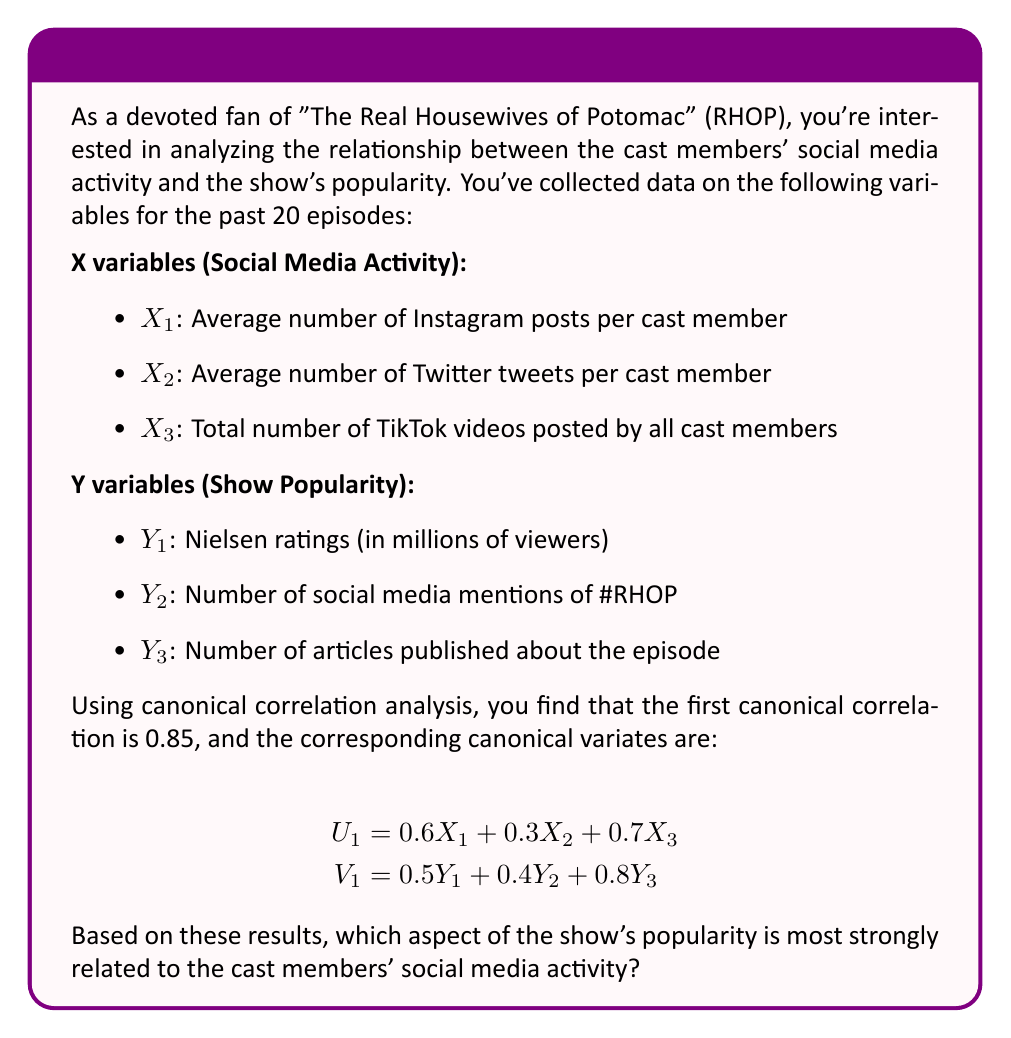Provide a solution to this math problem. To determine which aspect of the show's popularity is most strongly related to the cast members' social media activity, we need to analyze the coefficients of the canonical variate $V_1$, which represents the show's popularity. The larger the absolute value of the coefficient, the stronger the relationship between that variable and the overall canonical correlation.

Let's break down the analysis step-by-step:

1. Recall the equation for $V_1$:
   $$V_1 = 0.5Y_1 + 0.4Y_2 + 0.8Y_3$$

2. Compare the absolute values of the coefficients:
   $|0.5|$ for $Y_1$ (Nielsen ratings)
   $|0.4|$ for $Y_2$ (Number of social media mentions)
   $|0.8|$ for $Y_3$ (Number of articles published)

3. The largest coefficient in absolute value is 0.8, which corresponds to $Y_3$, the number of articles published about the episode.

4. This means that the number of articles published about the episode has the strongest relationship with the linear combination of social media activity variables represented by $U_1$.

5. It's worth noting that all aspects of show popularity contribute to the canonical correlation, but the number of articles published has the most substantial impact in this particular canonical variate.

Therefore, based on the given canonical correlation analysis results, the number of articles published about the episode (Y_3) is most strongly related to the cast members' social media activity.
Answer: Number of articles published about the episode ($Y_3$) 